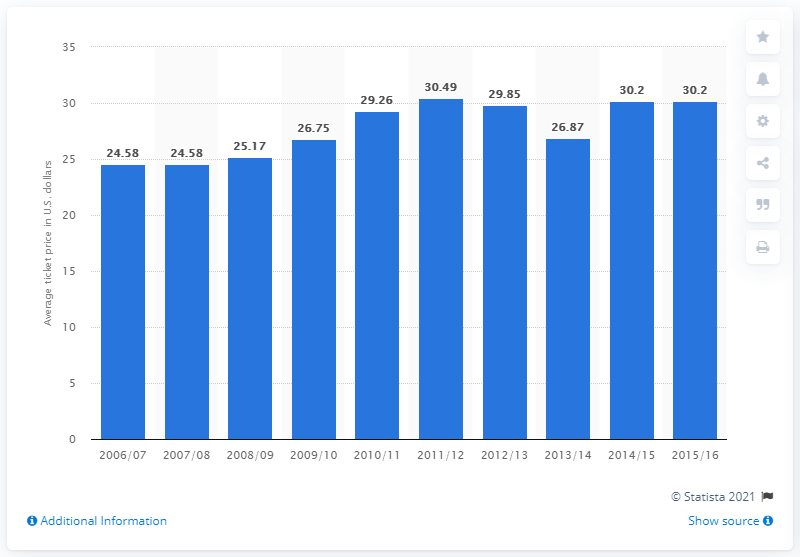Specify some key components in this picture. In the 2006/2007 season, the average ticket price for New Orleans Pelicans games was 24.58 dollars. The average ticket price for New Orleans Pelicans games changed in the year 2015/16. 